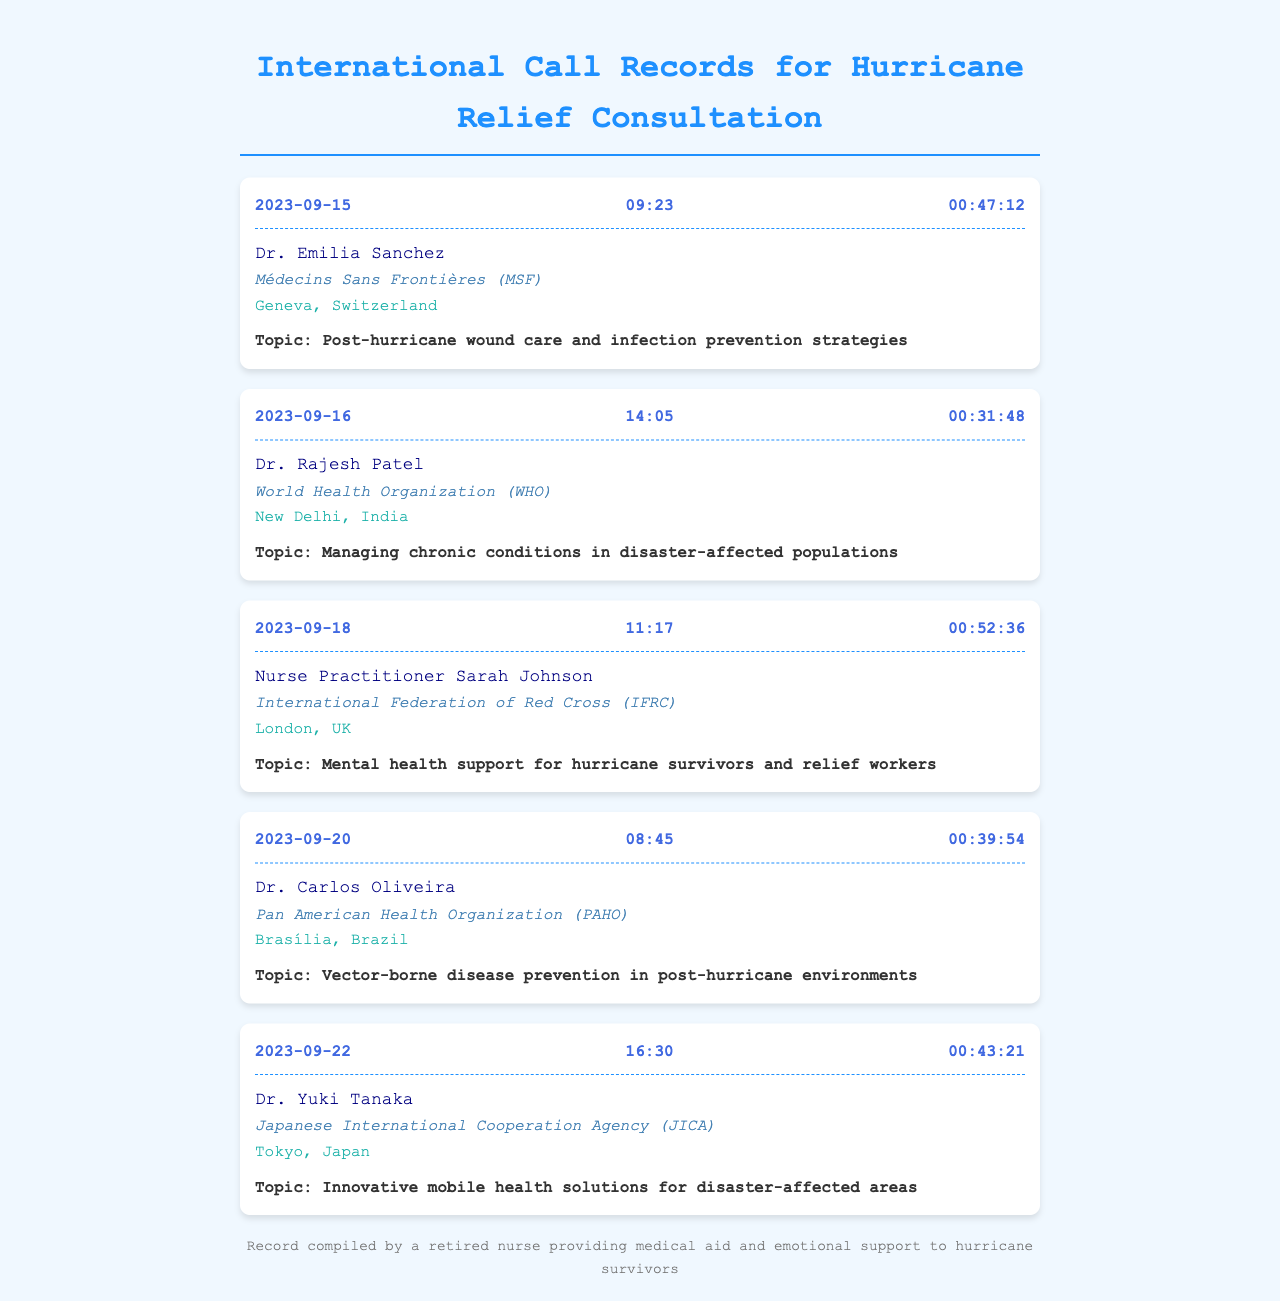What is the date of the first call? The first call is recorded on September 15, 2023.
Answer: September 15, 2023 Who did the nurse call on September 20, 2023? On September 20, 2023, the nurse called Dr. Carlos Oliveira.
Answer: Dr. Carlos Oliveira What organization is associated with Nurse Practitioner Sarah Johnson? Sarah Johnson is with the International Federation of Red Cross (IFRC).
Answer: International Federation of Red Cross (IFRC) How long was the call with Dr. Yuki Tanaka? The call with Dr. Yuki Tanaka lasted for 43 minutes and 21 seconds.
Answer: 00:43:21 What topic did Dr. Rajesh Patel discuss? Dr. Rajesh Patel discussed managing chronic conditions in disaster-affected populations.
Answer: Managing chronic conditions in disaster-affected populations Which city is Dr. Carlos Oliveira located in? Dr. Carlos Oliveira is located in Brasília.
Answer: Brasília What is the total number of calls listed in the records? There are five calls listed in the records.
Answer: Five Which organization's representative is located in Geneva? The representative in Geneva is Dr. Emilia Sanchez from Médecins Sans Frontières (MSF).
Answer: Médecins Sans Frontières (MSF) What was the main focus of the call with Dr. Yuki Tanaka? The main focus was on innovative mobile health solutions for disaster-affected areas.
Answer: Innovative mobile health solutions for disaster-affected areas 